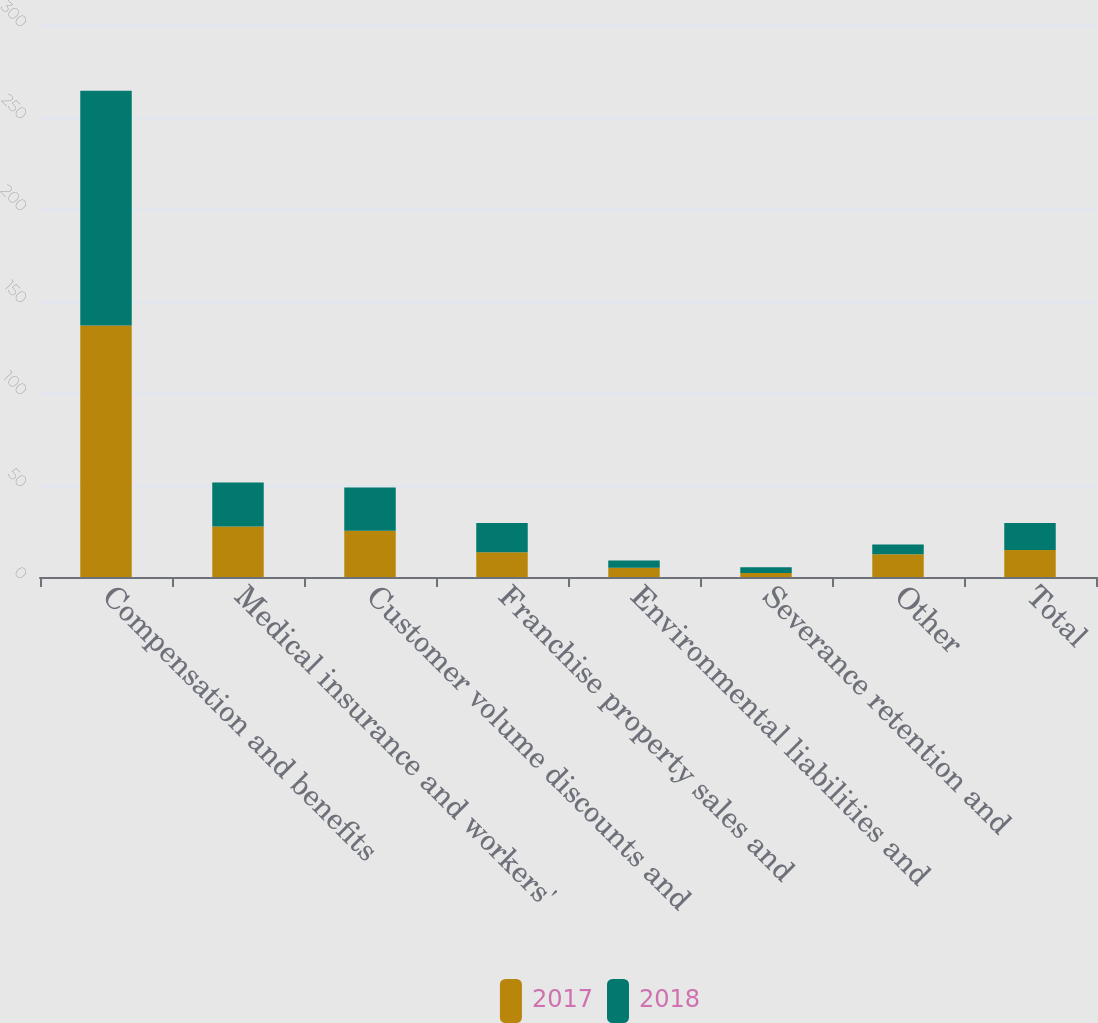Convert chart to OTSL. <chart><loc_0><loc_0><loc_500><loc_500><stacked_bar_chart><ecel><fcel>Compensation and benefits<fcel>Medical insurance and workers'<fcel>Customer volume discounts and<fcel>Franchise property sales and<fcel>Environmental liabilities and<fcel>Severance retention and<fcel>Other<fcel>Total<nl><fcel>2017<fcel>136.7<fcel>27.5<fcel>25.2<fcel>13.4<fcel>5<fcel>2.2<fcel>12.4<fcel>14.7<nl><fcel>2018<fcel>127.5<fcel>23.9<fcel>23.4<fcel>16<fcel>4<fcel>3.1<fcel>5.3<fcel>14.7<nl></chart> 